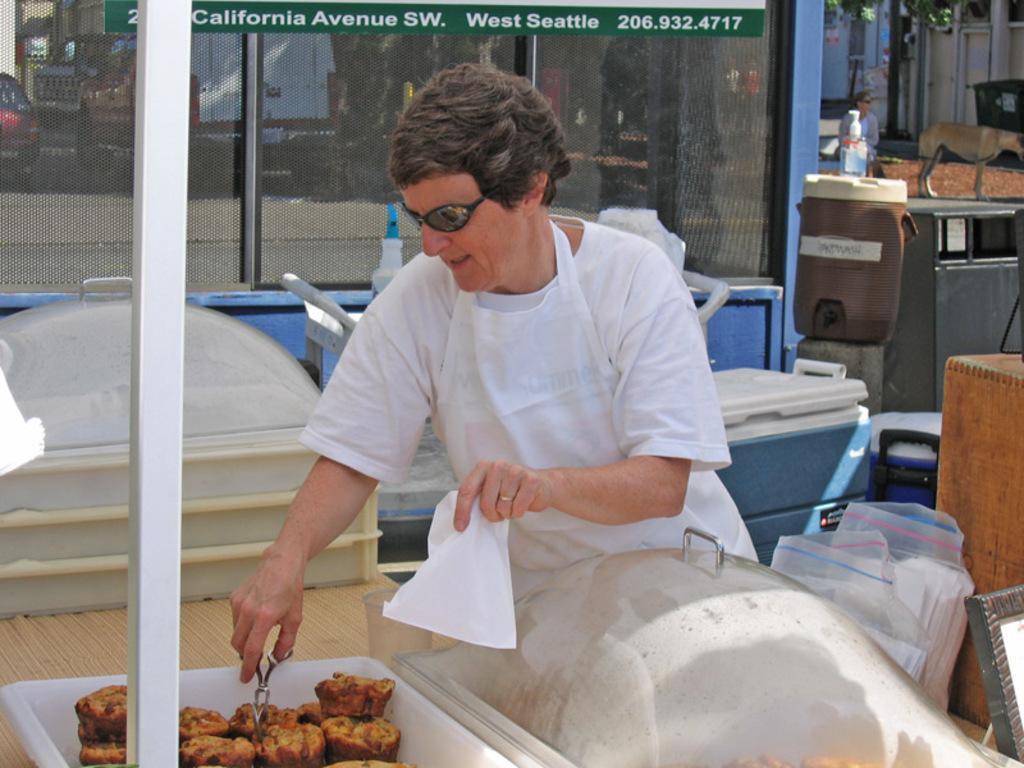Describe this image in one or two sentences. There is a person standing and holding cover and scissors,we can see lids,food,covers and objects on the table. In the background we can see boxes,water can,bottle,person,animal and glass,through this glass we can see vehicles. 